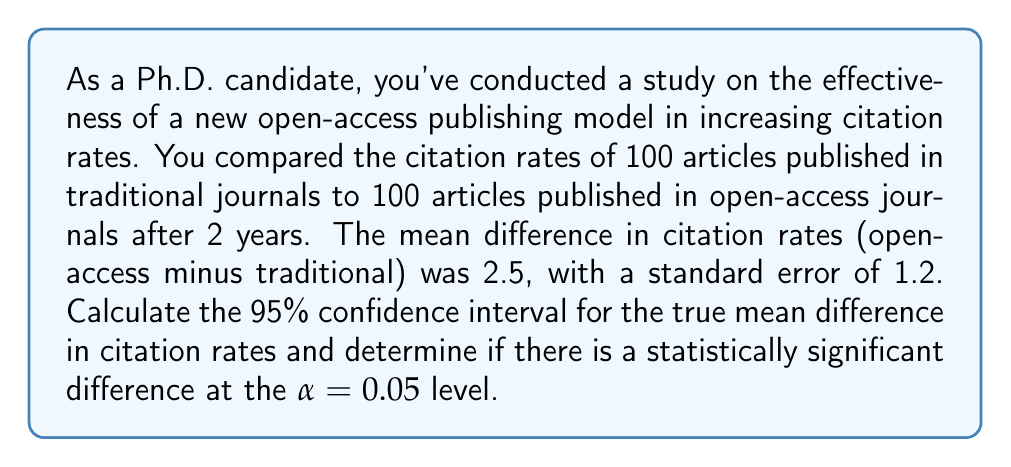Give your solution to this math problem. To solve this problem, we'll follow these steps:

1. Calculate the 95% confidence interval
2. Interpret the confidence interval
3. Determine statistical significance using the p-value

Step 1: Calculate the 95% confidence interval

The formula for a 95% confidence interval is:

$$ \text{CI} = \bar{x} \pm (t_{\alpha/2} \times SE) $$

Where:
- $\bar{x}$ is the sample mean difference (2.5)
- $t_{\alpha/2}$ is the t-value for a 95% CI with df = n - 1 = 199 (approximately 1.96 for large sample sizes)
- SE is the standard error (1.2)

Plugging in the values:

$$ \text{CI} = 2.5 \pm (1.96 \times 1.2) $$
$$ \text{CI} = 2.5 \pm 2.352 $$

Lower bound: $2.5 - 2.352 = 0.148$
Upper bound: $2.5 + 2.352 = 4.852$

Step 2: Interpret the confidence interval

The 95% CI is (0.148, 4.852). This means we can be 95% confident that the true population mean difference in citation rates between open-access and traditional journals lies between 0.148 and 4.852.

Step 3: Determine statistical significance using the p-value

To calculate the p-value, we'll use the t-statistic:

$$ t = \frac{\bar{x}}{SE} = \frac{2.5}{1.2} = 2.083 $$

For a two-tailed test with df = 199, the p-value associated with t = 2.083 is approximately 0.0385.

Since the p-value (0.0385) is less than the significance level (α = 0.05), we reject the null hypothesis. This indicates that there is a statistically significant difference in citation rates between open-access and traditional journals.

We can also determine statistical significance from the confidence interval. Since the CI does not include 0, we can conclude that the difference is statistically significant at the 0.05 level.
Answer: The 95% confidence interval for the true mean difference in citation rates is (0.148, 4.852). The difference is statistically significant at the α = 0.05 level (p-value ≈ 0.0385 < 0.05). 